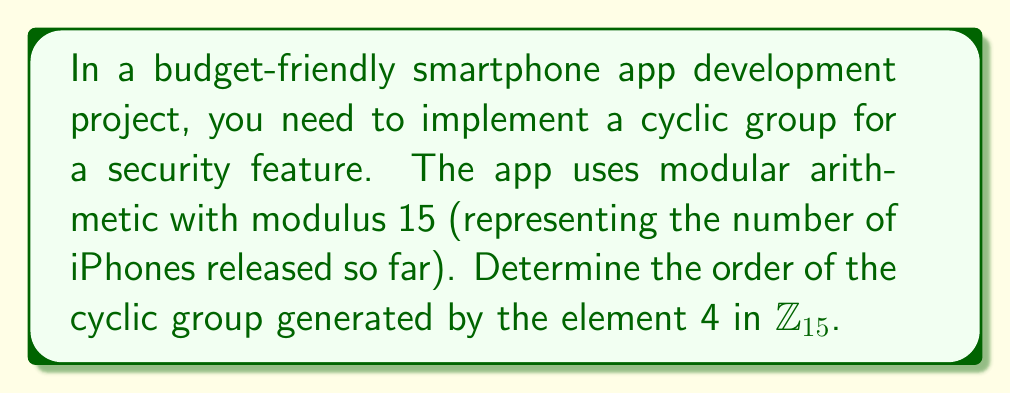Help me with this question. To find the order of the cyclic group generated by 4 in $\mathbb{Z}_{15}$, we need to determine the smallest positive integer $n$ such that $4^n \equiv 1 \pmod{15}$. Let's calculate the powers of 4 modulo 15:

1. $4^1 \equiv 4 \pmod{15}$
2. $4^2 \equiv 16 \equiv 1 \pmod{15}$

We see that $4^2 \equiv 1 \pmod{15}$, so the order of the cyclic group is 2.

To verify, let's check the elements of the group:
$$\langle 4 \rangle = \{4^1 \bmod 15, 4^2 \bmod 15\} = \{4, 1\}$$

Indeed, this group has 2 elements, confirming our calculation.

The order of 4 in $\mathbb{Z}_{15}$ is 2 because:

1. $4^2 = 16 \equiv 1 \pmod{15}$
2. 2 is the smallest positive integer that satisfies this condition

This result means that in your app's security feature, the cyclic group generated by 4 will only have two distinct elements, which could be useful for implementing a simple toggle or binary state in the security mechanism.
Answer: The order of the cyclic group generated by 4 in $\mathbb{Z}_{15}$ is 2. 